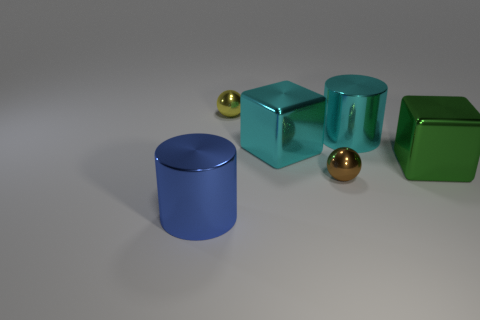Add 1 green rubber blocks. How many objects exist? 7 Subtract 1 balls. How many balls are left? 1 Subtract all cyan cylinders. How many cylinders are left? 1 Subtract all cylinders. How many objects are left? 4 Subtract all red cylinders. Subtract all green cubes. How many cylinders are left? 2 Subtract all cyan metal blocks. Subtract all cyan metal cylinders. How many objects are left? 4 Add 3 green blocks. How many green blocks are left? 4 Add 5 brown objects. How many brown objects exist? 6 Subtract 1 cyan cylinders. How many objects are left? 5 